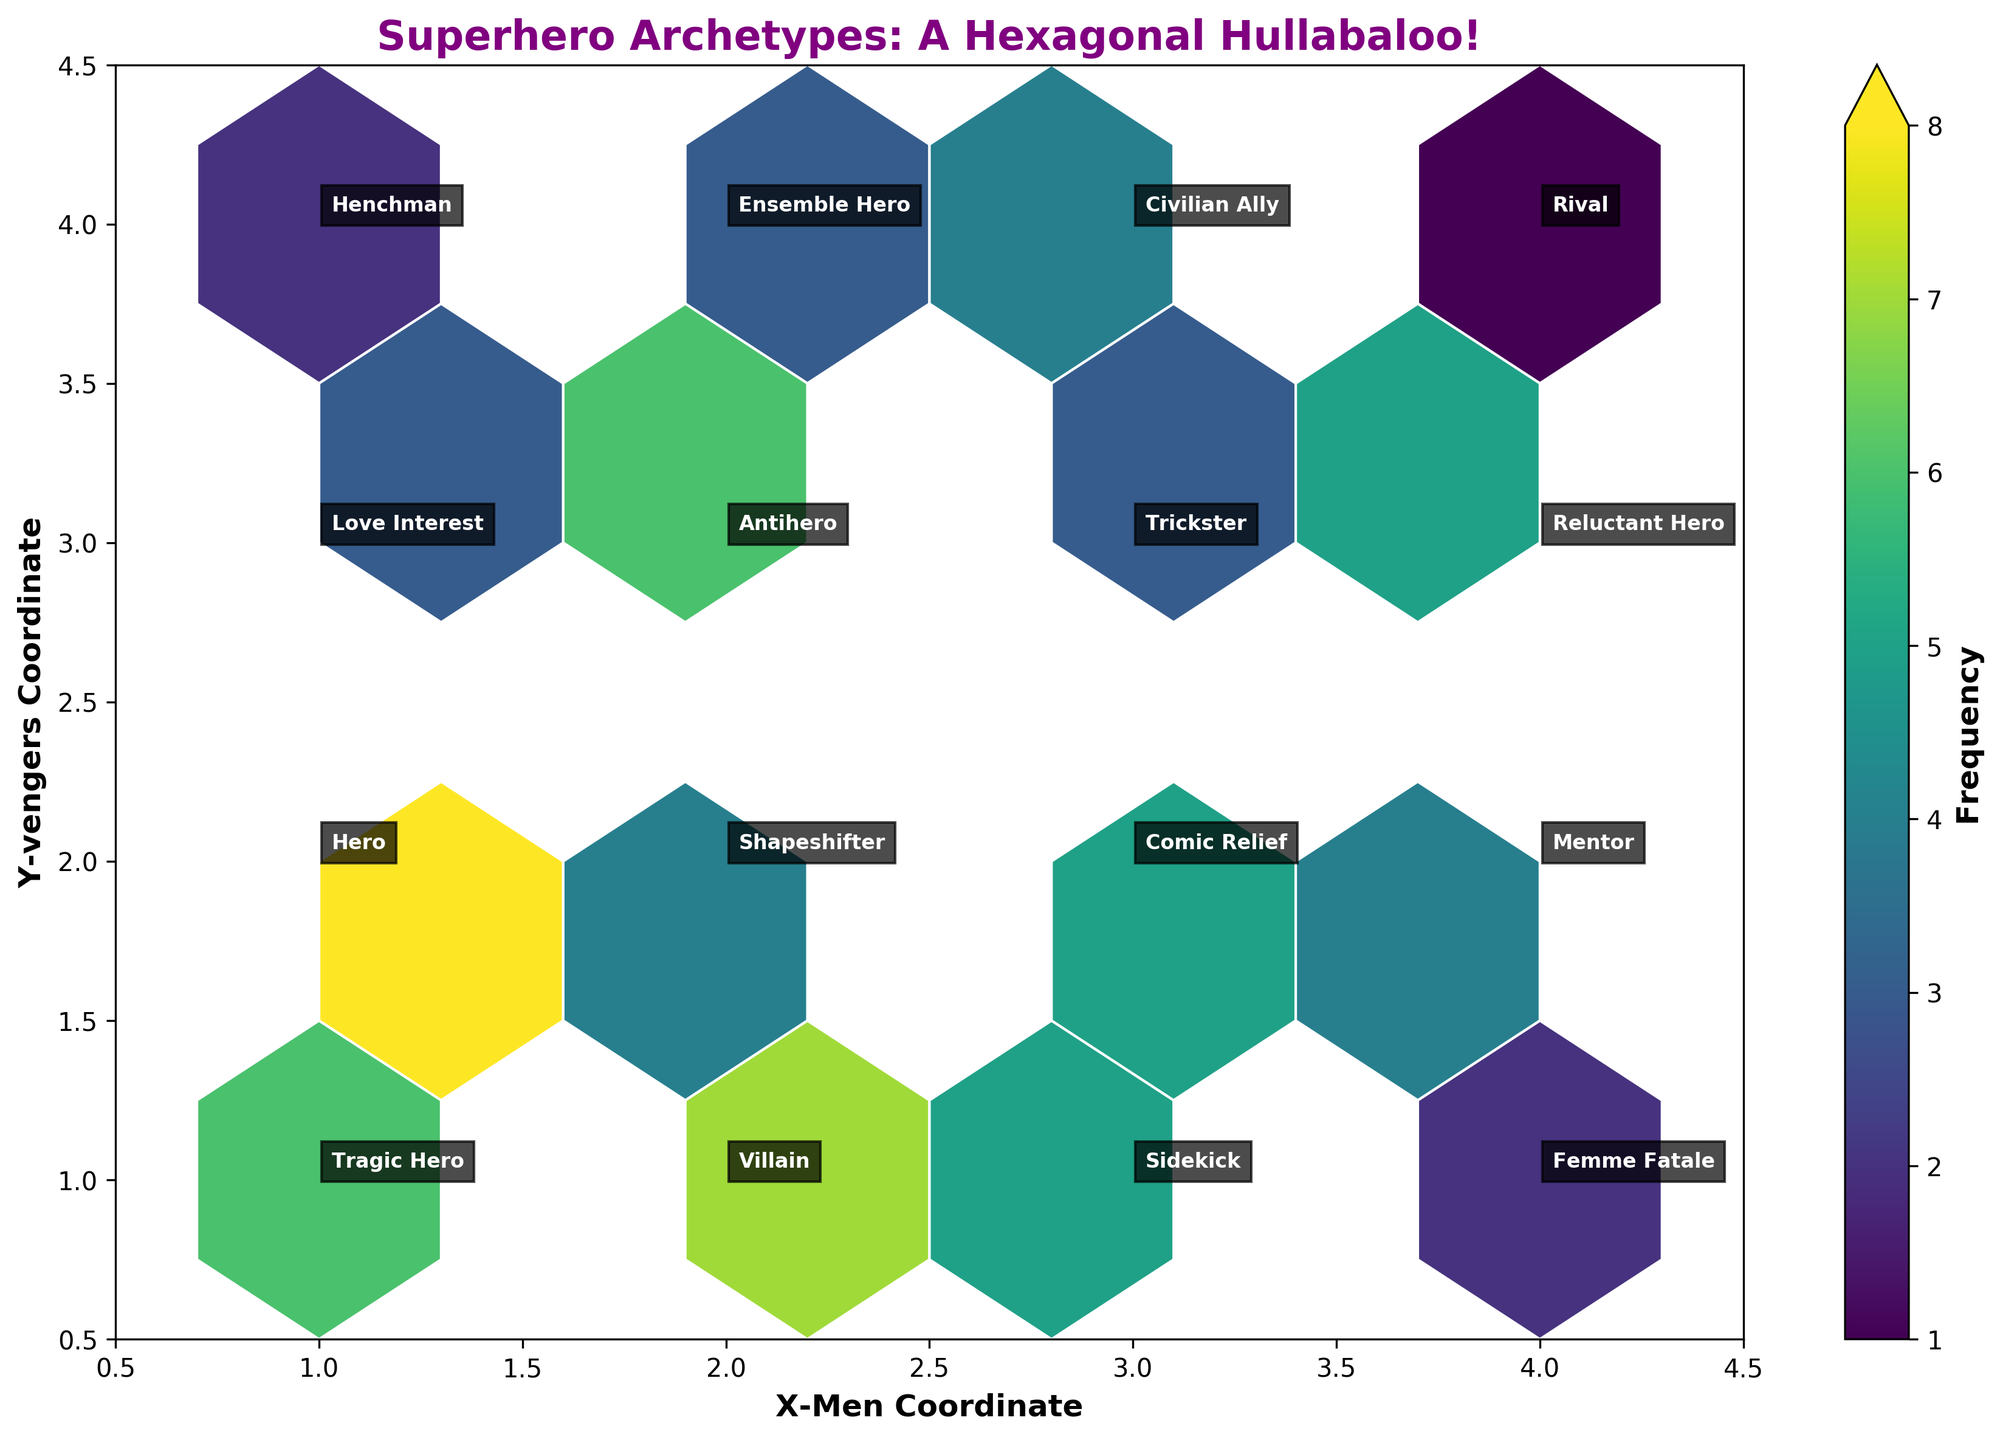What is the title of the Hexbin Plot? The title of the Hexbin Plot is usually located at the top of the figure, in this case, it's bolded and purple.
Answer: Superhero Archetypes: A Hexagonal Hullabaloo! What are the labels of the two axes? Axis labels are identified near the axis lines, often in bold.
Answer: X-Men Coordinate and Y-vengers Coordinate Which character archetype appears most frequently in the Marvel Studios films? To determine this, check the data points labeled with Marvel Studios and compare their frequencies.
Answer: Hero What is the sum of frequencies for archetypes with 'Hero' in their name? Look for the rows with 'Hero' in their name, sum their frequencies: Hero (8), Reluctant Hero (5), Tragic Hero (6), Ensemble Hero (3). Total: 8 + 5 + 6 + 3 = 22
Answer: 22 Which studio has the data point at (1,4), and what is the archetype? Locate the coordinates (1,4) on the plot and identify the studio and archetype.
Answer: DC Films and Henchman Among the archetypes labeled as Marvel Studios, which appears least frequently, and what is its frequency? Check the frequencies of all rows labeled with Marvel Studios and identify the smallest frequency.
Answer: Sidekick and 5 Compare the frequency of the 'Villain' archetype in Warner Bros. with 'Antihero' in DC Films. Which is higher? Look at the frequency of Villain in Warner Bros (7) and Antihero in DC Films (6), and compare them.
Answer: Villain Which grid cell has the highest value of frequency, and what is that frequency? Observe the color intensity in the hexbin cells, the highest frequency typically correlates with the cell having the darkest color. Check the colorbar for the exact frequency.
Answer: (1,2) with frequency 8 How many different studios are represented in the Hexbin Plot? Count the unique studios displayed in the annotations.
Answer: 5 What is the difference in frequency between the Comic Relief archetype in Marvel Studios and the Love Interest archetype in Sony Pictures? Comic Relief in Marvel Studios has a frequency of 5, and Love Interest in Sony Pictures has a frequency of 3. The difference is 5 - 3 = 2.
Answer: 2 